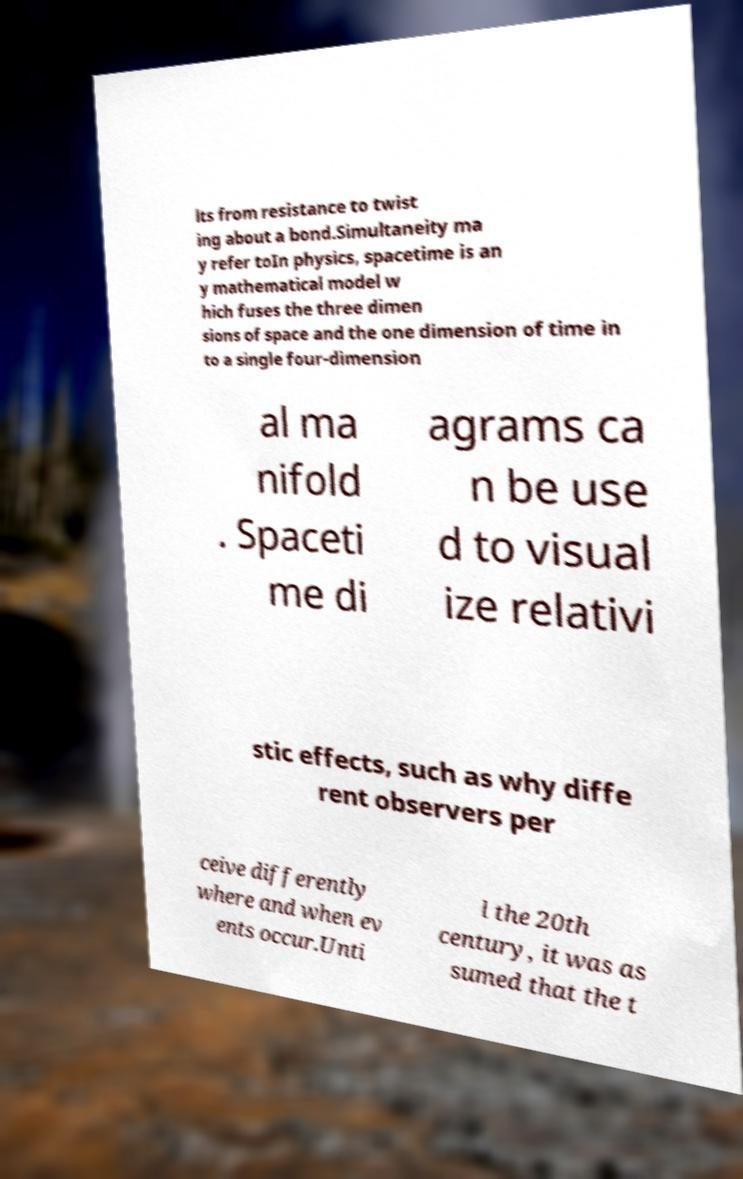There's text embedded in this image that I need extracted. Can you transcribe it verbatim? lts from resistance to twist ing about a bond.Simultaneity ma y refer toIn physics, spacetime is an y mathematical model w hich fuses the three dimen sions of space and the one dimension of time in to a single four-dimension al ma nifold . Spaceti me di agrams ca n be use d to visual ize relativi stic effects, such as why diffe rent observers per ceive differently where and when ev ents occur.Unti l the 20th century, it was as sumed that the t 